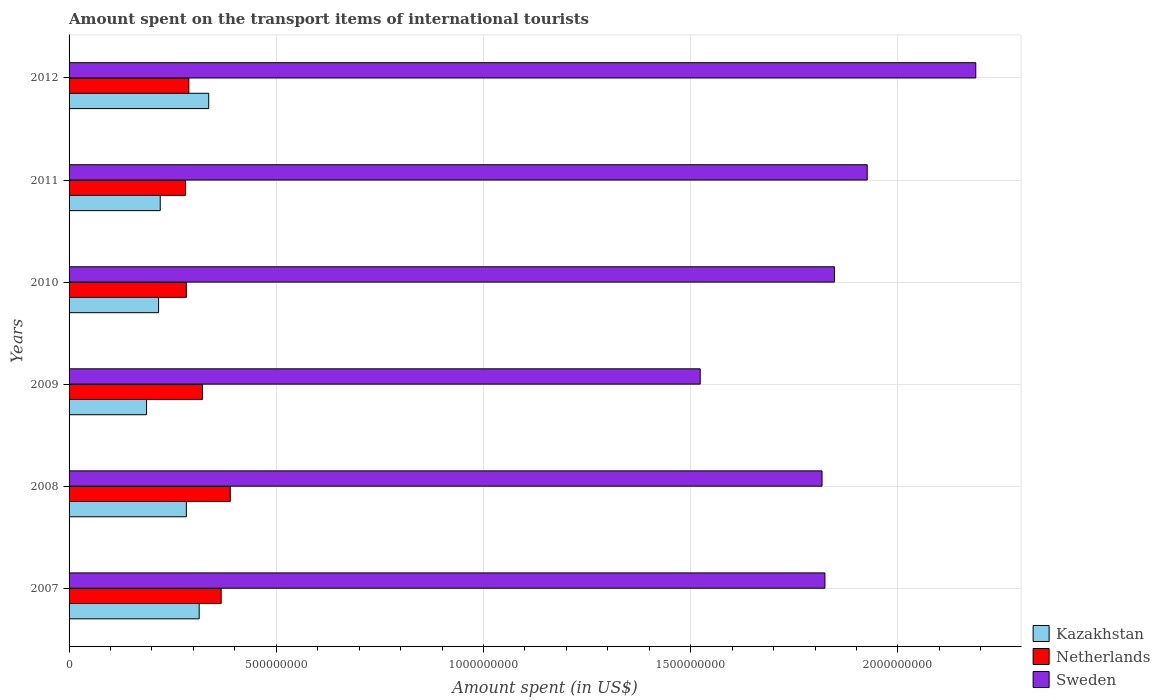How many different coloured bars are there?
Your answer should be compact. 3. Are the number of bars per tick equal to the number of legend labels?
Your answer should be very brief. Yes. Are the number of bars on each tick of the Y-axis equal?
Give a very brief answer. Yes. How many bars are there on the 2nd tick from the bottom?
Ensure brevity in your answer.  3. What is the label of the 1st group of bars from the top?
Ensure brevity in your answer.  2012. What is the amount spent on the transport items of international tourists in Sweden in 2012?
Offer a terse response. 2.19e+09. Across all years, what is the maximum amount spent on the transport items of international tourists in Sweden?
Your answer should be very brief. 2.19e+09. Across all years, what is the minimum amount spent on the transport items of international tourists in Netherlands?
Make the answer very short. 2.81e+08. In which year was the amount spent on the transport items of international tourists in Sweden minimum?
Keep it short and to the point. 2009. What is the total amount spent on the transport items of international tourists in Netherlands in the graph?
Offer a terse response. 1.93e+09. What is the difference between the amount spent on the transport items of international tourists in Netherlands in 2007 and that in 2009?
Your answer should be compact. 4.50e+07. What is the difference between the amount spent on the transport items of international tourists in Sweden in 2009 and the amount spent on the transport items of international tourists in Netherlands in 2008?
Offer a terse response. 1.13e+09. What is the average amount spent on the transport items of international tourists in Sweden per year?
Your response must be concise. 1.85e+09. In the year 2009, what is the difference between the amount spent on the transport items of international tourists in Sweden and amount spent on the transport items of international tourists in Netherlands?
Make the answer very short. 1.20e+09. What is the ratio of the amount spent on the transport items of international tourists in Netherlands in 2007 to that in 2009?
Your answer should be very brief. 1.14. Is the amount spent on the transport items of international tourists in Netherlands in 2007 less than that in 2008?
Ensure brevity in your answer.  Yes. What is the difference between the highest and the second highest amount spent on the transport items of international tourists in Netherlands?
Make the answer very short. 2.20e+07. What is the difference between the highest and the lowest amount spent on the transport items of international tourists in Sweden?
Keep it short and to the point. 6.65e+08. In how many years, is the amount spent on the transport items of international tourists in Sweden greater than the average amount spent on the transport items of international tourists in Sweden taken over all years?
Offer a very short reply. 2. Is the sum of the amount spent on the transport items of international tourists in Sweden in 2008 and 2010 greater than the maximum amount spent on the transport items of international tourists in Netherlands across all years?
Make the answer very short. Yes. What does the 3rd bar from the top in 2007 represents?
Provide a short and direct response. Kazakhstan. Is it the case that in every year, the sum of the amount spent on the transport items of international tourists in Kazakhstan and amount spent on the transport items of international tourists in Netherlands is greater than the amount spent on the transport items of international tourists in Sweden?
Provide a short and direct response. No. Are all the bars in the graph horizontal?
Your answer should be very brief. Yes. What is the difference between two consecutive major ticks on the X-axis?
Your answer should be very brief. 5.00e+08. Does the graph contain any zero values?
Your response must be concise. No. Where does the legend appear in the graph?
Keep it short and to the point. Bottom right. How are the legend labels stacked?
Your answer should be compact. Vertical. What is the title of the graph?
Your answer should be compact. Amount spent on the transport items of international tourists. Does "OECD members" appear as one of the legend labels in the graph?
Offer a terse response. No. What is the label or title of the X-axis?
Provide a succinct answer. Amount spent (in US$). What is the label or title of the Y-axis?
Ensure brevity in your answer.  Years. What is the Amount spent (in US$) in Kazakhstan in 2007?
Keep it short and to the point. 3.14e+08. What is the Amount spent (in US$) of Netherlands in 2007?
Offer a very short reply. 3.67e+08. What is the Amount spent (in US$) of Sweden in 2007?
Keep it short and to the point. 1.82e+09. What is the Amount spent (in US$) in Kazakhstan in 2008?
Ensure brevity in your answer.  2.83e+08. What is the Amount spent (in US$) of Netherlands in 2008?
Your answer should be very brief. 3.89e+08. What is the Amount spent (in US$) of Sweden in 2008?
Give a very brief answer. 1.82e+09. What is the Amount spent (in US$) of Kazakhstan in 2009?
Your answer should be very brief. 1.87e+08. What is the Amount spent (in US$) in Netherlands in 2009?
Offer a very short reply. 3.22e+08. What is the Amount spent (in US$) of Sweden in 2009?
Offer a very short reply. 1.52e+09. What is the Amount spent (in US$) in Kazakhstan in 2010?
Your answer should be very brief. 2.16e+08. What is the Amount spent (in US$) of Netherlands in 2010?
Ensure brevity in your answer.  2.83e+08. What is the Amount spent (in US$) in Sweden in 2010?
Offer a very short reply. 1.85e+09. What is the Amount spent (in US$) of Kazakhstan in 2011?
Make the answer very short. 2.20e+08. What is the Amount spent (in US$) in Netherlands in 2011?
Your answer should be very brief. 2.81e+08. What is the Amount spent (in US$) in Sweden in 2011?
Provide a succinct answer. 1.93e+09. What is the Amount spent (in US$) in Kazakhstan in 2012?
Offer a very short reply. 3.37e+08. What is the Amount spent (in US$) of Netherlands in 2012?
Offer a terse response. 2.89e+08. What is the Amount spent (in US$) in Sweden in 2012?
Keep it short and to the point. 2.19e+09. Across all years, what is the maximum Amount spent (in US$) of Kazakhstan?
Your answer should be compact. 3.37e+08. Across all years, what is the maximum Amount spent (in US$) of Netherlands?
Provide a succinct answer. 3.89e+08. Across all years, what is the maximum Amount spent (in US$) in Sweden?
Your answer should be compact. 2.19e+09. Across all years, what is the minimum Amount spent (in US$) of Kazakhstan?
Offer a very short reply. 1.87e+08. Across all years, what is the minimum Amount spent (in US$) in Netherlands?
Make the answer very short. 2.81e+08. Across all years, what is the minimum Amount spent (in US$) in Sweden?
Keep it short and to the point. 1.52e+09. What is the total Amount spent (in US$) of Kazakhstan in the graph?
Provide a short and direct response. 1.56e+09. What is the total Amount spent (in US$) in Netherlands in the graph?
Ensure brevity in your answer.  1.93e+09. What is the total Amount spent (in US$) in Sweden in the graph?
Make the answer very short. 1.11e+1. What is the difference between the Amount spent (in US$) of Kazakhstan in 2007 and that in 2008?
Make the answer very short. 3.10e+07. What is the difference between the Amount spent (in US$) in Netherlands in 2007 and that in 2008?
Give a very brief answer. -2.20e+07. What is the difference between the Amount spent (in US$) in Sweden in 2007 and that in 2008?
Give a very brief answer. 7.00e+06. What is the difference between the Amount spent (in US$) of Kazakhstan in 2007 and that in 2009?
Your answer should be very brief. 1.27e+08. What is the difference between the Amount spent (in US$) of Netherlands in 2007 and that in 2009?
Ensure brevity in your answer.  4.50e+07. What is the difference between the Amount spent (in US$) of Sweden in 2007 and that in 2009?
Your answer should be very brief. 3.01e+08. What is the difference between the Amount spent (in US$) in Kazakhstan in 2007 and that in 2010?
Give a very brief answer. 9.80e+07. What is the difference between the Amount spent (in US$) of Netherlands in 2007 and that in 2010?
Keep it short and to the point. 8.40e+07. What is the difference between the Amount spent (in US$) of Sweden in 2007 and that in 2010?
Provide a short and direct response. -2.30e+07. What is the difference between the Amount spent (in US$) of Kazakhstan in 2007 and that in 2011?
Make the answer very short. 9.40e+07. What is the difference between the Amount spent (in US$) in Netherlands in 2007 and that in 2011?
Offer a terse response. 8.60e+07. What is the difference between the Amount spent (in US$) in Sweden in 2007 and that in 2011?
Offer a very short reply. -1.02e+08. What is the difference between the Amount spent (in US$) in Kazakhstan in 2007 and that in 2012?
Your response must be concise. -2.30e+07. What is the difference between the Amount spent (in US$) in Netherlands in 2007 and that in 2012?
Ensure brevity in your answer.  7.80e+07. What is the difference between the Amount spent (in US$) of Sweden in 2007 and that in 2012?
Your answer should be compact. -3.64e+08. What is the difference between the Amount spent (in US$) of Kazakhstan in 2008 and that in 2009?
Give a very brief answer. 9.60e+07. What is the difference between the Amount spent (in US$) of Netherlands in 2008 and that in 2009?
Keep it short and to the point. 6.70e+07. What is the difference between the Amount spent (in US$) of Sweden in 2008 and that in 2009?
Offer a terse response. 2.94e+08. What is the difference between the Amount spent (in US$) of Kazakhstan in 2008 and that in 2010?
Provide a succinct answer. 6.70e+07. What is the difference between the Amount spent (in US$) of Netherlands in 2008 and that in 2010?
Give a very brief answer. 1.06e+08. What is the difference between the Amount spent (in US$) in Sweden in 2008 and that in 2010?
Make the answer very short. -3.00e+07. What is the difference between the Amount spent (in US$) in Kazakhstan in 2008 and that in 2011?
Ensure brevity in your answer.  6.30e+07. What is the difference between the Amount spent (in US$) in Netherlands in 2008 and that in 2011?
Make the answer very short. 1.08e+08. What is the difference between the Amount spent (in US$) of Sweden in 2008 and that in 2011?
Provide a succinct answer. -1.09e+08. What is the difference between the Amount spent (in US$) of Kazakhstan in 2008 and that in 2012?
Your answer should be very brief. -5.40e+07. What is the difference between the Amount spent (in US$) in Netherlands in 2008 and that in 2012?
Your response must be concise. 1.00e+08. What is the difference between the Amount spent (in US$) in Sweden in 2008 and that in 2012?
Keep it short and to the point. -3.71e+08. What is the difference between the Amount spent (in US$) in Kazakhstan in 2009 and that in 2010?
Your answer should be compact. -2.90e+07. What is the difference between the Amount spent (in US$) in Netherlands in 2009 and that in 2010?
Give a very brief answer. 3.90e+07. What is the difference between the Amount spent (in US$) in Sweden in 2009 and that in 2010?
Keep it short and to the point. -3.24e+08. What is the difference between the Amount spent (in US$) in Kazakhstan in 2009 and that in 2011?
Make the answer very short. -3.30e+07. What is the difference between the Amount spent (in US$) of Netherlands in 2009 and that in 2011?
Offer a terse response. 4.10e+07. What is the difference between the Amount spent (in US$) in Sweden in 2009 and that in 2011?
Provide a succinct answer. -4.03e+08. What is the difference between the Amount spent (in US$) in Kazakhstan in 2009 and that in 2012?
Your answer should be compact. -1.50e+08. What is the difference between the Amount spent (in US$) of Netherlands in 2009 and that in 2012?
Your answer should be very brief. 3.30e+07. What is the difference between the Amount spent (in US$) of Sweden in 2009 and that in 2012?
Provide a succinct answer. -6.65e+08. What is the difference between the Amount spent (in US$) of Kazakhstan in 2010 and that in 2011?
Provide a succinct answer. -4.00e+06. What is the difference between the Amount spent (in US$) of Netherlands in 2010 and that in 2011?
Give a very brief answer. 2.00e+06. What is the difference between the Amount spent (in US$) in Sweden in 2010 and that in 2011?
Offer a very short reply. -7.90e+07. What is the difference between the Amount spent (in US$) in Kazakhstan in 2010 and that in 2012?
Make the answer very short. -1.21e+08. What is the difference between the Amount spent (in US$) in Netherlands in 2010 and that in 2012?
Provide a short and direct response. -6.00e+06. What is the difference between the Amount spent (in US$) of Sweden in 2010 and that in 2012?
Offer a very short reply. -3.41e+08. What is the difference between the Amount spent (in US$) in Kazakhstan in 2011 and that in 2012?
Your answer should be very brief. -1.17e+08. What is the difference between the Amount spent (in US$) of Netherlands in 2011 and that in 2012?
Your answer should be compact. -8.00e+06. What is the difference between the Amount spent (in US$) in Sweden in 2011 and that in 2012?
Ensure brevity in your answer.  -2.62e+08. What is the difference between the Amount spent (in US$) in Kazakhstan in 2007 and the Amount spent (in US$) in Netherlands in 2008?
Offer a terse response. -7.50e+07. What is the difference between the Amount spent (in US$) in Kazakhstan in 2007 and the Amount spent (in US$) in Sweden in 2008?
Ensure brevity in your answer.  -1.50e+09. What is the difference between the Amount spent (in US$) of Netherlands in 2007 and the Amount spent (in US$) of Sweden in 2008?
Provide a succinct answer. -1.45e+09. What is the difference between the Amount spent (in US$) in Kazakhstan in 2007 and the Amount spent (in US$) in Netherlands in 2009?
Ensure brevity in your answer.  -8.00e+06. What is the difference between the Amount spent (in US$) of Kazakhstan in 2007 and the Amount spent (in US$) of Sweden in 2009?
Your answer should be compact. -1.21e+09. What is the difference between the Amount spent (in US$) in Netherlands in 2007 and the Amount spent (in US$) in Sweden in 2009?
Provide a succinct answer. -1.16e+09. What is the difference between the Amount spent (in US$) of Kazakhstan in 2007 and the Amount spent (in US$) of Netherlands in 2010?
Offer a terse response. 3.10e+07. What is the difference between the Amount spent (in US$) in Kazakhstan in 2007 and the Amount spent (in US$) in Sweden in 2010?
Ensure brevity in your answer.  -1.53e+09. What is the difference between the Amount spent (in US$) of Netherlands in 2007 and the Amount spent (in US$) of Sweden in 2010?
Offer a very short reply. -1.48e+09. What is the difference between the Amount spent (in US$) of Kazakhstan in 2007 and the Amount spent (in US$) of Netherlands in 2011?
Provide a succinct answer. 3.30e+07. What is the difference between the Amount spent (in US$) in Kazakhstan in 2007 and the Amount spent (in US$) in Sweden in 2011?
Provide a succinct answer. -1.61e+09. What is the difference between the Amount spent (in US$) in Netherlands in 2007 and the Amount spent (in US$) in Sweden in 2011?
Offer a very short reply. -1.56e+09. What is the difference between the Amount spent (in US$) of Kazakhstan in 2007 and the Amount spent (in US$) of Netherlands in 2012?
Keep it short and to the point. 2.50e+07. What is the difference between the Amount spent (in US$) of Kazakhstan in 2007 and the Amount spent (in US$) of Sweden in 2012?
Your answer should be very brief. -1.87e+09. What is the difference between the Amount spent (in US$) of Netherlands in 2007 and the Amount spent (in US$) of Sweden in 2012?
Make the answer very short. -1.82e+09. What is the difference between the Amount spent (in US$) in Kazakhstan in 2008 and the Amount spent (in US$) in Netherlands in 2009?
Offer a terse response. -3.90e+07. What is the difference between the Amount spent (in US$) in Kazakhstan in 2008 and the Amount spent (in US$) in Sweden in 2009?
Offer a terse response. -1.24e+09. What is the difference between the Amount spent (in US$) of Netherlands in 2008 and the Amount spent (in US$) of Sweden in 2009?
Offer a very short reply. -1.13e+09. What is the difference between the Amount spent (in US$) in Kazakhstan in 2008 and the Amount spent (in US$) in Netherlands in 2010?
Make the answer very short. 0. What is the difference between the Amount spent (in US$) of Kazakhstan in 2008 and the Amount spent (in US$) of Sweden in 2010?
Make the answer very short. -1.56e+09. What is the difference between the Amount spent (in US$) in Netherlands in 2008 and the Amount spent (in US$) in Sweden in 2010?
Keep it short and to the point. -1.46e+09. What is the difference between the Amount spent (in US$) of Kazakhstan in 2008 and the Amount spent (in US$) of Sweden in 2011?
Ensure brevity in your answer.  -1.64e+09. What is the difference between the Amount spent (in US$) of Netherlands in 2008 and the Amount spent (in US$) of Sweden in 2011?
Give a very brief answer. -1.54e+09. What is the difference between the Amount spent (in US$) in Kazakhstan in 2008 and the Amount spent (in US$) in Netherlands in 2012?
Offer a terse response. -6.00e+06. What is the difference between the Amount spent (in US$) in Kazakhstan in 2008 and the Amount spent (in US$) in Sweden in 2012?
Give a very brief answer. -1.90e+09. What is the difference between the Amount spent (in US$) of Netherlands in 2008 and the Amount spent (in US$) of Sweden in 2012?
Keep it short and to the point. -1.80e+09. What is the difference between the Amount spent (in US$) of Kazakhstan in 2009 and the Amount spent (in US$) of Netherlands in 2010?
Ensure brevity in your answer.  -9.60e+07. What is the difference between the Amount spent (in US$) in Kazakhstan in 2009 and the Amount spent (in US$) in Sweden in 2010?
Your answer should be compact. -1.66e+09. What is the difference between the Amount spent (in US$) in Netherlands in 2009 and the Amount spent (in US$) in Sweden in 2010?
Give a very brief answer. -1.52e+09. What is the difference between the Amount spent (in US$) in Kazakhstan in 2009 and the Amount spent (in US$) in Netherlands in 2011?
Your answer should be very brief. -9.40e+07. What is the difference between the Amount spent (in US$) in Kazakhstan in 2009 and the Amount spent (in US$) in Sweden in 2011?
Your answer should be very brief. -1.74e+09. What is the difference between the Amount spent (in US$) of Netherlands in 2009 and the Amount spent (in US$) of Sweden in 2011?
Your answer should be compact. -1.60e+09. What is the difference between the Amount spent (in US$) in Kazakhstan in 2009 and the Amount spent (in US$) in Netherlands in 2012?
Keep it short and to the point. -1.02e+08. What is the difference between the Amount spent (in US$) of Kazakhstan in 2009 and the Amount spent (in US$) of Sweden in 2012?
Ensure brevity in your answer.  -2.00e+09. What is the difference between the Amount spent (in US$) in Netherlands in 2009 and the Amount spent (in US$) in Sweden in 2012?
Offer a terse response. -1.87e+09. What is the difference between the Amount spent (in US$) of Kazakhstan in 2010 and the Amount spent (in US$) of Netherlands in 2011?
Your answer should be very brief. -6.50e+07. What is the difference between the Amount spent (in US$) in Kazakhstan in 2010 and the Amount spent (in US$) in Sweden in 2011?
Offer a terse response. -1.71e+09. What is the difference between the Amount spent (in US$) in Netherlands in 2010 and the Amount spent (in US$) in Sweden in 2011?
Give a very brief answer. -1.64e+09. What is the difference between the Amount spent (in US$) of Kazakhstan in 2010 and the Amount spent (in US$) of Netherlands in 2012?
Offer a very short reply. -7.30e+07. What is the difference between the Amount spent (in US$) of Kazakhstan in 2010 and the Amount spent (in US$) of Sweden in 2012?
Give a very brief answer. -1.97e+09. What is the difference between the Amount spent (in US$) of Netherlands in 2010 and the Amount spent (in US$) of Sweden in 2012?
Offer a terse response. -1.90e+09. What is the difference between the Amount spent (in US$) in Kazakhstan in 2011 and the Amount spent (in US$) in Netherlands in 2012?
Provide a short and direct response. -6.90e+07. What is the difference between the Amount spent (in US$) of Kazakhstan in 2011 and the Amount spent (in US$) of Sweden in 2012?
Make the answer very short. -1.97e+09. What is the difference between the Amount spent (in US$) of Netherlands in 2011 and the Amount spent (in US$) of Sweden in 2012?
Offer a terse response. -1.91e+09. What is the average Amount spent (in US$) in Kazakhstan per year?
Offer a very short reply. 2.60e+08. What is the average Amount spent (in US$) of Netherlands per year?
Your answer should be compact. 3.22e+08. What is the average Amount spent (in US$) of Sweden per year?
Offer a very short reply. 1.85e+09. In the year 2007, what is the difference between the Amount spent (in US$) in Kazakhstan and Amount spent (in US$) in Netherlands?
Provide a succinct answer. -5.30e+07. In the year 2007, what is the difference between the Amount spent (in US$) in Kazakhstan and Amount spent (in US$) in Sweden?
Ensure brevity in your answer.  -1.51e+09. In the year 2007, what is the difference between the Amount spent (in US$) of Netherlands and Amount spent (in US$) of Sweden?
Your response must be concise. -1.46e+09. In the year 2008, what is the difference between the Amount spent (in US$) of Kazakhstan and Amount spent (in US$) of Netherlands?
Keep it short and to the point. -1.06e+08. In the year 2008, what is the difference between the Amount spent (in US$) of Kazakhstan and Amount spent (in US$) of Sweden?
Your answer should be compact. -1.53e+09. In the year 2008, what is the difference between the Amount spent (in US$) in Netherlands and Amount spent (in US$) in Sweden?
Keep it short and to the point. -1.43e+09. In the year 2009, what is the difference between the Amount spent (in US$) in Kazakhstan and Amount spent (in US$) in Netherlands?
Offer a very short reply. -1.35e+08. In the year 2009, what is the difference between the Amount spent (in US$) of Kazakhstan and Amount spent (in US$) of Sweden?
Your answer should be compact. -1.34e+09. In the year 2009, what is the difference between the Amount spent (in US$) in Netherlands and Amount spent (in US$) in Sweden?
Give a very brief answer. -1.20e+09. In the year 2010, what is the difference between the Amount spent (in US$) in Kazakhstan and Amount spent (in US$) in Netherlands?
Provide a succinct answer. -6.70e+07. In the year 2010, what is the difference between the Amount spent (in US$) of Kazakhstan and Amount spent (in US$) of Sweden?
Provide a succinct answer. -1.63e+09. In the year 2010, what is the difference between the Amount spent (in US$) of Netherlands and Amount spent (in US$) of Sweden?
Provide a short and direct response. -1.56e+09. In the year 2011, what is the difference between the Amount spent (in US$) of Kazakhstan and Amount spent (in US$) of Netherlands?
Your answer should be very brief. -6.10e+07. In the year 2011, what is the difference between the Amount spent (in US$) of Kazakhstan and Amount spent (in US$) of Sweden?
Give a very brief answer. -1.71e+09. In the year 2011, what is the difference between the Amount spent (in US$) of Netherlands and Amount spent (in US$) of Sweden?
Your answer should be very brief. -1.64e+09. In the year 2012, what is the difference between the Amount spent (in US$) in Kazakhstan and Amount spent (in US$) in Netherlands?
Offer a terse response. 4.80e+07. In the year 2012, what is the difference between the Amount spent (in US$) in Kazakhstan and Amount spent (in US$) in Sweden?
Ensure brevity in your answer.  -1.85e+09. In the year 2012, what is the difference between the Amount spent (in US$) in Netherlands and Amount spent (in US$) in Sweden?
Make the answer very short. -1.90e+09. What is the ratio of the Amount spent (in US$) in Kazakhstan in 2007 to that in 2008?
Provide a short and direct response. 1.11. What is the ratio of the Amount spent (in US$) of Netherlands in 2007 to that in 2008?
Your answer should be compact. 0.94. What is the ratio of the Amount spent (in US$) in Sweden in 2007 to that in 2008?
Offer a terse response. 1. What is the ratio of the Amount spent (in US$) of Kazakhstan in 2007 to that in 2009?
Keep it short and to the point. 1.68. What is the ratio of the Amount spent (in US$) of Netherlands in 2007 to that in 2009?
Offer a terse response. 1.14. What is the ratio of the Amount spent (in US$) of Sweden in 2007 to that in 2009?
Your answer should be very brief. 1.2. What is the ratio of the Amount spent (in US$) in Kazakhstan in 2007 to that in 2010?
Ensure brevity in your answer.  1.45. What is the ratio of the Amount spent (in US$) of Netherlands in 2007 to that in 2010?
Keep it short and to the point. 1.3. What is the ratio of the Amount spent (in US$) in Sweden in 2007 to that in 2010?
Ensure brevity in your answer.  0.99. What is the ratio of the Amount spent (in US$) in Kazakhstan in 2007 to that in 2011?
Your response must be concise. 1.43. What is the ratio of the Amount spent (in US$) in Netherlands in 2007 to that in 2011?
Your answer should be very brief. 1.31. What is the ratio of the Amount spent (in US$) of Sweden in 2007 to that in 2011?
Your answer should be compact. 0.95. What is the ratio of the Amount spent (in US$) of Kazakhstan in 2007 to that in 2012?
Your response must be concise. 0.93. What is the ratio of the Amount spent (in US$) in Netherlands in 2007 to that in 2012?
Make the answer very short. 1.27. What is the ratio of the Amount spent (in US$) in Sweden in 2007 to that in 2012?
Your answer should be compact. 0.83. What is the ratio of the Amount spent (in US$) in Kazakhstan in 2008 to that in 2009?
Your answer should be compact. 1.51. What is the ratio of the Amount spent (in US$) of Netherlands in 2008 to that in 2009?
Offer a terse response. 1.21. What is the ratio of the Amount spent (in US$) in Sweden in 2008 to that in 2009?
Offer a very short reply. 1.19. What is the ratio of the Amount spent (in US$) of Kazakhstan in 2008 to that in 2010?
Offer a terse response. 1.31. What is the ratio of the Amount spent (in US$) in Netherlands in 2008 to that in 2010?
Provide a succinct answer. 1.37. What is the ratio of the Amount spent (in US$) in Sweden in 2008 to that in 2010?
Give a very brief answer. 0.98. What is the ratio of the Amount spent (in US$) of Kazakhstan in 2008 to that in 2011?
Ensure brevity in your answer.  1.29. What is the ratio of the Amount spent (in US$) in Netherlands in 2008 to that in 2011?
Your answer should be very brief. 1.38. What is the ratio of the Amount spent (in US$) of Sweden in 2008 to that in 2011?
Ensure brevity in your answer.  0.94. What is the ratio of the Amount spent (in US$) of Kazakhstan in 2008 to that in 2012?
Give a very brief answer. 0.84. What is the ratio of the Amount spent (in US$) of Netherlands in 2008 to that in 2012?
Keep it short and to the point. 1.35. What is the ratio of the Amount spent (in US$) in Sweden in 2008 to that in 2012?
Your response must be concise. 0.83. What is the ratio of the Amount spent (in US$) of Kazakhstan in 2009 to that in 2010?
Ensure brevity in your answer.  0.87. What is the ratio of the Amount spent (in US$) in Netherlands in 2009 to that in 2010?
Keep it short and to the point. 1.14. What is the ratio of the Amount spent (in US$) in Sweden in 2009 to that in 2010?
Your response must be concise. 0.82. What is the ratio of the Amount spent (in US$) in Kazakhstan in 2009 to that in 2011?
Make the answer very short. 0.85. What is the ratio of the Amount spent (in US$) in Netherlands in 2009 to that in 2011?
Provide a short and direct response. 1.15. What is the ratio of the Amount spent (in US$) of Sweden in 2009 to that in 2011?
Your answer should be very brief. 0.79. What is the ratio of the Amount spent (in US$) of Kazakhstan in 2009 to that in 2012?
Keep it short and to the point. 0.55. What is the ratio of the Amount spent (in US$) in Netherlands in 2009 to that in 2012?
Your answer should be very brief. 1.11. What is the ratio of the Amount spent (in US$) of Sweden in 2009 to that in 2012?
Offer a terse response. 0.7. What is the ratio of the Amount spent (in US$) in Kazakhstan in 2010 to that in 2011?
Ensure brevity in your answer.  0.98. What is the ratio of the Amount spent (in US$) in Netherlands in 2010 to that in 2011?
Ensure brevity in your answer.  1.01. What is the ratio of the Amount spent (in US$) of Kazakhstan in 2010 to that in 2012?
Offer a terse response. 0.64. What is the ratio of the Amount spent (in US$) in Netherlands in 2010 to that in 2012?
Offer a very short reply. 0.98. What is the ratio of the Amount spent (in US$) of Sweden in 2010 to that in 2012?
Provide a short and direct response. 0.84. What is the ratio of the Amount spent (in US$) of Kazakhstan in 2011 to that in 2012?
Offer a terse response. 0.65. What is the ratio of the Amount spent (in US$) of Netherlands in 2011 to that in 2012?
Provide a succinct answer. 0.97. What is the ratio of the Amount spent (in US$) in Sweden in 2011 to that in 2012?
Ensure brevity in your answer.  0.88. What is the difference between the highest and the second highest Amount spent (in US$) in Kazakhstan?
Provide a short and direct response. 2.30e+07. What is the difference between the highest and the second highest Amount spent (in US$) in Netherlands?
Provide a short and direct response. 2.20e+07. What is the difference between the highest and the second highest Amount spent (in US$) of Sweden?
Your response must be concise. 2.62e+08. What is the difference between the highest and the lowest Amount spent (in US$) of Kazakhstan?
Offer a very short reply. 1.50e+08. What is the difference between the highest and the lowest Amount spent (in US$) of Netherlands?
Provide a short and direct response. 1.08e+08. What is the difference between the highest and the lowest Amount spent (in US$) in Sweden?
Offer a very short reply. 6.65e+08. 